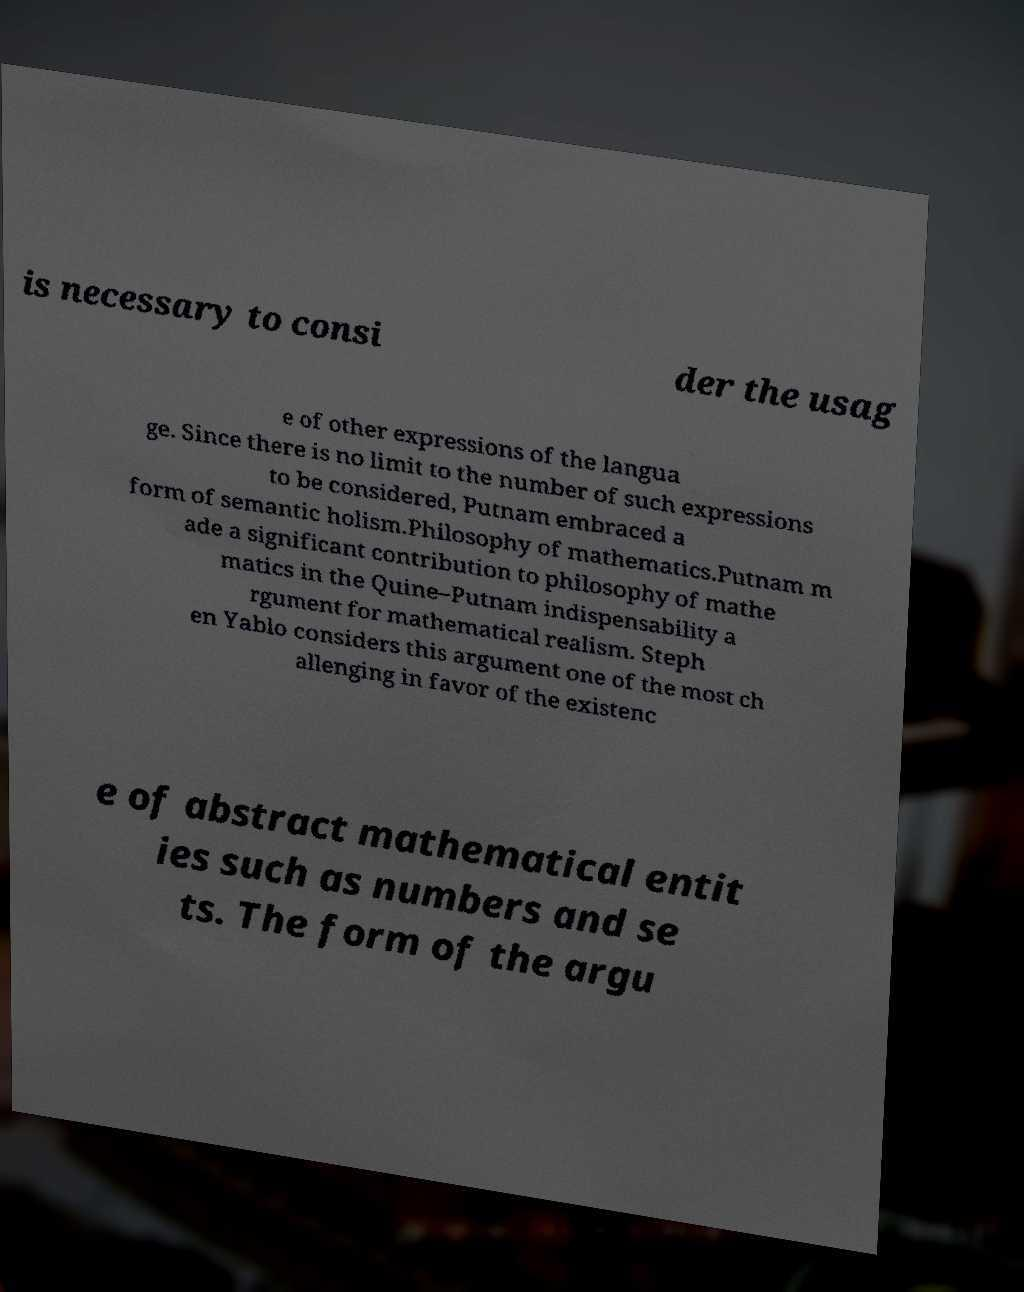Can you read and provide the text displayed in the image?This photo seems to have some interesting text. Can you extract and type it out for me? is necessary to consi der the usag e of other expressions of the langua ge. Since there is no limit to the number of such expressions to be considered, Putnam embraced a form of semantic holism.Philosophy of mathematics.Putnam m ade a significant contribution to philosophy of mathe matics in the Quine–Putnam indispensability a rgument for mathematical realism. Steph en Yablo considers this argument one of the most ch allenging in favor of the existenc e of abstract mathematical entit ies such as numbers and se ts. The form of the argu 